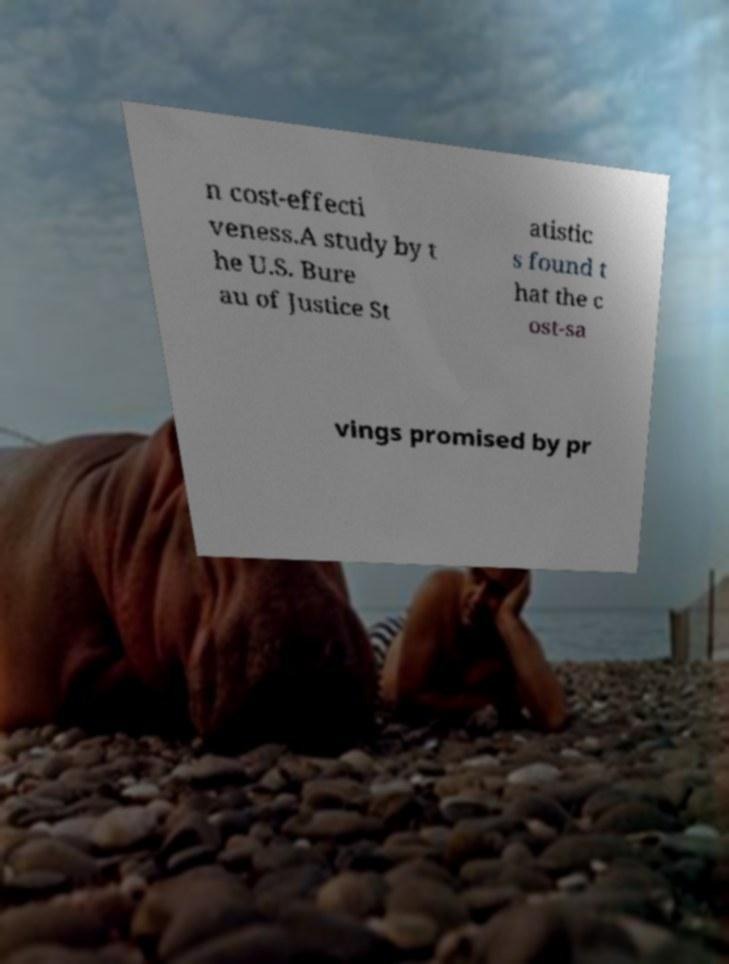Can you accurately transcribe the text from the provided image for me? n cost-effecti veness.A study by t he U.S. Bure au of Justice St atistic s found t hat the c ost-sa vings promised by pr 